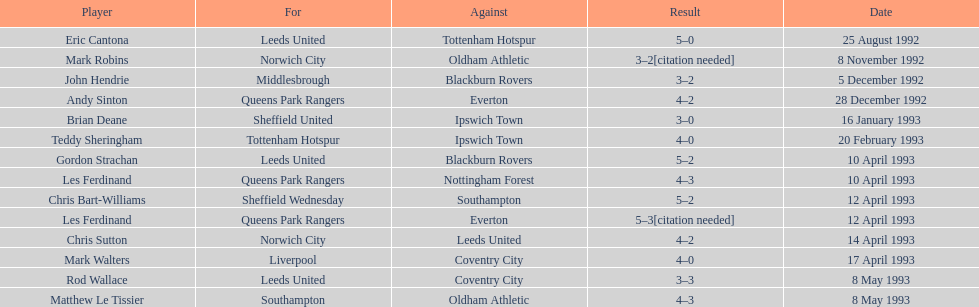Which team did liverpool go up against? Coventry City. 